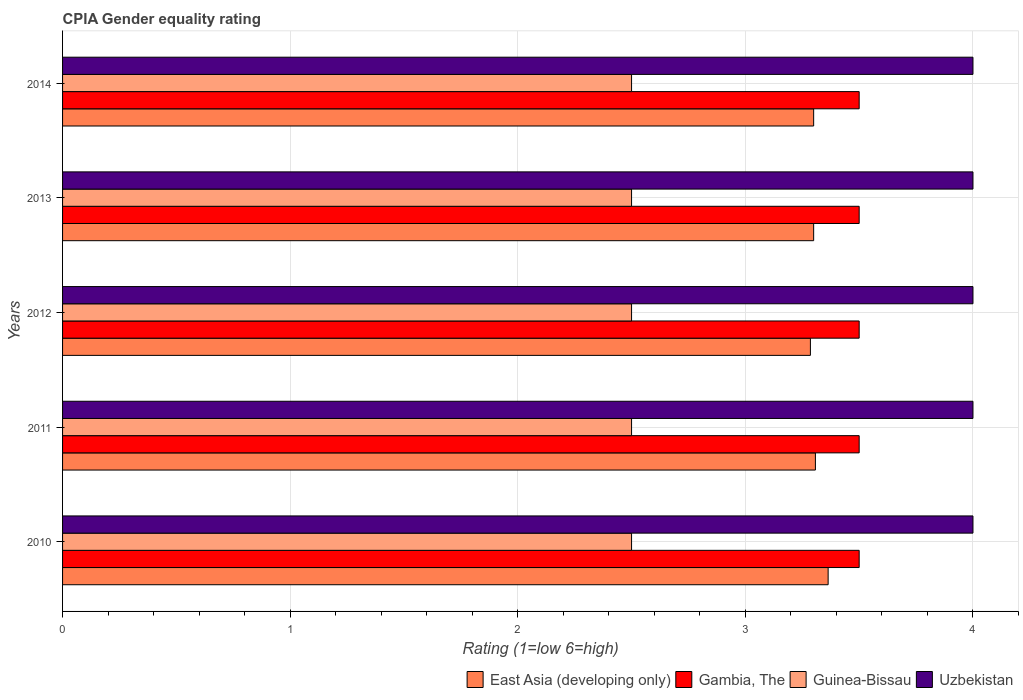How many different coloured bars are there?
Offer a terse response. 4. Are the number of bars on each tick of the Y-axis equal?
Offer a terse response. Yes. How many bars are there on the 4th tick from the bottom?
Give a very brief answer. 4. Across all years, what is the maximum CPIA rating in East Asia (developing only)?
Offer a very short reply. 3.36. In which year was the CPIA rating in Gambia, The maximum?
Make the answer very short. 2010. In which year was the CPIA rating in East Asia (developing only) minimum?
Your answer should be very brief. 2012. In the year 2013, what is the difference between the CPIA rating in East Asia (developing only) and CPIA rating in Guinea-Bissau?
Provide a short and direct response. 0.8. What is the ratio of the CPIA rating in East Asia (developing only) in 2010 to that in 2014?
Keep it short and to the point. 1.02. Is the CPIA rating in East Asia (developing only) in 2013 less than that in 2014?
Your answer should be very brief. No. Is the difference between the CPIA rating in East Asia (developing only) in 2012 and 2014 greater than the difference between the CPIA rating in Guinea-Bissau in 2012 and 2014?
Your response must be concise. No. In how many years, is the CPIA rating in Uzbekistan greater than the average CPIA rating in Uzbekistan taken over all years?
Give a very brief answer. 0. What does the 1st bar from the top in 2010 represents?
Offer a very short reply. Uzbekistan. What does the 3rd bar from the bottom in 2012 represents?
Make the answer very short. Guinea-Bissau. Is it the case that in every year, the sum of the CPIA rating in Gambia, The and CPIA rating in Uzbekistan is greater than the CPIA rating in Guinea-Bissau?
Offer a terse response. Yes. Are all the bars in the graph horizontal?
Your response must be concise. Yes. How many years are there in the graph?
Make the answer very short. 5. Does the graph contain grids?
Offer a terse response. Yes. Where does the legend appear in the graph?
Make the answer very short. Bottom right. What is the title of the graph?
Keep it short and to the point. CPIA Gender equality rating. Does "Belgium" appear as one of the legend labels in the graph?
Your answer should be compact. No. What is the label or title of the X-axis?
Your answer should be compact. Rating (1=low 6=high). What is the Rating (1=low 6=high) in East Asia (developing only) in 2010?
Ensure brevity in your answer.  3.36. What is the Rating (1=low 6=high) of Uzbekistan in 2010?
Offer a terse response. 4. What is the Rating (1=low 6=high) of East Asia (developing only) in 2011?
Keep it short and to the point. 3.31. What is the Rating (1=low 6=high) in Uzbekistan in 2011?
Your answer should be very brief. 4. What is the Rating (1=low 6=high) in East Asia (developing only) in 2012?
Ensure brevity in your answer.  3.29. What is the Rating (1=low 6=high) in Uzbekistan in 2012?
Your response must be concise. 4. What is the Rating (1=low 6=high) of Gambia, The in 2013?
Provide a short and direct response. 3.5. What is the Rating (1=low 6=high) in Uzbekistan in 2014?
Provide a short and direct response. 4. Across all years, what is the maximum Rating (1=low 6=high) of East Asia (developing only)?
Make the answer very short. 3.36. Across all years, what is the maximum Rating (1=low 6=high) of Gambia, The?
Your response must be concise. 3.5. Across all years, what is the minimum Rating (1=low 6=high) of East Asia (developing only)?
Offer a very short reply. 3.29. Across all years, what is the minimum Rating (1=low 6=high) of Gambia, The?
Give a very brief answer. 3.5. Across all years, what is the minimum Rating (1=low 6=high) in Guinea-Bissau?
Offer a very short reply. 2.5. Across all years, what is the minimum Rating (1=low 6=high) in Uzbekistan?
Offer a very short reply. 4. What is the total Rating (1=low 6=high) of East Asia (developing only) in the graph?
Offer a very short reply. 16.56. What is the total Rating (1=low 6=high) in Uzbekistan in the graph?
Keep it short and to the point. 20. What is the difference between the Rating (1=low 6=high) of East Asia (developing only) in 2010 and that in 2011?
Offer a terse response. 0.06. What is the difference between the Rating (1=low 6=high) of East Asia (developing only) in 2010 and that in 2012?
Provide a short and direct response. 0.08. What is the difference between the Rating (1=low 6=high) of Gambia, The in 2010 and that in 2012?
Keep it short and to the point. 0. What is the difference between the Rating (1=low 6=high) in East Asia (developing only) in 2010 and that in 2013?
Your response must be concise. 0.06. What is the difference between the Rating (1=low 6=high) of Guinea-Bissau in 2010 and that in 2013?
Your answer should be compact. 0. What is the difference between the Rating (1=low 6=high) in Uzbekistan in 2010 and that in 2013?
Offer a terse response. 0. What is the difference between the Rating (1=low 6=high) in East Asia (developing only) in 2010 and that in 2014?
Provide a short and direct response. 0.06. What is the difference between the Rating (1=low 6=high) in Guinea-Bissau in 2010 and that in 2014?
Make the answer very short. 0. What is the difference between the Rating (1=low 6=high) of Uzbekistan in 2010 and that in 2014?
Offer a very short reply. 0. What is the difference between the Rating (1=low 6=high) of East Asia (developing only) in 2011 and that in 2012?
Ensure brevity in your answer.  0.02. What is the difference between the Rating (1=low 6=high) of Gambia, The in 2011 and that in 2012?
Offer a terse response. 0. What is the difference between the Rating (1=low 6=high) in Uzbekistan in 2011 and that in 2012?
Ensure brevity in your answer.  0. What is the difference between the Rating (1=low 6=high) of East Asia (developing only) in 2011 and that in 2013?
Your answer should be very brief. 0.01. What is the difference between the Rating (1=low 6=high) in Gambia, The in 2011 and that in 2013?
Keep it short and to the point. 0. What is the difference between the Rating (1=low 6=high) in Uzbekistan in 2011 and that in 2013?
Provide a short and direct response. 0. What is the difference between the Rating (1=low 6=high) of East Asia (developing only) in 2011 and that in 2014?
Provide a short and direct response. 0.01. What is the difference between the Rating (1=low 6=high) of Guinea-Bissau in 2011 and that in 2014?
Offer a very short reply. 0. What is the difference between the Rating (1=low 6=high) in Uzbekistan in 2011 and that in 2014?
Ensure brevity in your answer.  0. What is the difference between the Rating (1=low 6=high) in East Asia (developing only) in 2012 and that in 2013?
Your answer should be compact. -0.01. What is the difference between the Rating (1=low 6=high) of Gambia, The in 2012 and that in 2013?
Your answer should be compact. 0. What is the difference between the Rating (1=low 6=high) of Guinea-Bissau in 2012 and that in 2013?
Offer a very short reply. 0. What is the difference between the Rating (1=low 6=high) in East Asia (developing only) in 2012 and that in 2014?
Ensure brevity in your answer.  -0.01. What is the difference between the Rating (1=low 6=high) of Guinea-Bissau in 2012 and that in 2014?
Provide a short and direct response. 0. What is the difference between the Rating (1=low 6=high) of Uzbekistan in 2013 and that in 2014?
Your response must be concise. 0. What is the difference between the Rating (1=low 6=high) in East Asia (developing only) in 2010 and the Rating (1=low 6=high) in Gambia, The in 2011?
Provide a succinct answer. -0.14. What is the difference between the Rating (1=low 6=high) of East Asia (developing only) in 2010 and the Rating (1=low 6=high) of Guinea-Bissau in 2011?
Make the answer very short. 0.86. What is the difference between the Rating (1=low 6=high) in East Asia (developing only) in 2010 and the Rating (1=low 6=high) in Uzbekistan in 2011?
Ensure brevity in your answer.  -0.64. What is the difference between the Rating (1=low 6=high) of Gambia, The in 2010 and the Rating (1=low 6=high) of Guinea-Bissau in 2011?
Your answer should be very brief. 1. What is the difference between the Rating (1=low 6=high) in Guinea-Bissau in 2010 and the Rating (1=low 6=high) in Uzbekistan in 2011?
Make the answer very short. -1.5. What is the difference between the Rating (1=low 6=high) of East Asia (developing only) in 2010 and the Rating (1=low 6=high) of Gambia, The in 2012?
Offer a terse response. -0.14. What is the difference between the Rating (1=low 6=high) in East Asia (developing only) in 2010 and the Rating (1=low 6=high) in Guinea-Bissau in 2012?
Offer a terse response. 0.86. What is the difference between the Rating (1=low 6=high) of East Asia (developing only) in 2010 and the Rating (1=low 6=high) of Uzbekistan in 2012?
Keep it short and to the point. -0.64. What is the difference between the Rating (1=low 6=high) of Gambia, The in 2010 and the Rating (1=low 6=high) of Guinea-Bissau in 2012?
Ensure brevity in your answer.  1. What is the difference between the Rating (1=low 6=high) of Gambia, The in 2010 and the Rating (1=low 6=high) of Uzbekistan in 2012?
Keep it short and to the point. -0.5. What is the difference between the Rating (1=low 6=high) of Guinea-Bissau in 2010 and the Rating (1=low 6=high) of Uzbekistan in 2012?
Offer a very short reply. -1.5. What is the difference between the Rating (1=low 6=high) in East Asia (developing only) in 2010 and the Rating (1=low 6=high) in Gambia, The in 2013?
Give a very brief answer. -0.14. What is the difference between the Rating (1=low 6=high) of East Asia (developing only) in 2010 and the Rating (1=low 6=high) of Guinea-Bissau in 2013?
Your answer should be very brief. 0.86. What is the difference between the Rating (1=low 6=high) of East Asia (developing only) in 2010 and the Rating (1=low 6=high) of Uzbekistan in 2013?
Provide a short and direct response. -0.64. What is the difference between the Rating (1=low 6=high) in Gambia, The in 2010 and the Rating (1=low 6=high) in Guinea-Bissau in 2013?
Make the answer very short. 1. What is the difference between the Rating (1=low 6=high) of Guinea-Bissau in 2010 and the Rating (1=low 6=high) of Uzbekistan in 2013?
Ensure brevity in your answer.  -1.5. What is the difference between the Rating (1=low 6=high) in East Asia (developing only) in 2010 and the Rating (1=low 6=high) in Gambia, The in 2014?
Your response must be concise. -0.14. What is the difference between the Rating (1=low 6=high) in East Asia (developing only) in 2010 and the Rating (1=low 6=high) in Guinea-Bissau in 2014?
Your answer should be compact. 0.86. What is the difference between the Rating (1=low 6=high) of East Asia (developing only) in 2010 and the Rating (1=low 6=high) of Uzbekistan in 2014?
Provide a short and direct response. -0.64. What is the difference between the Rating (1=low 6=high) of Guinea-Bissau in 2010 and the Rating (1=low 6=high) of Uzbekistan in 2014?
Your answer should be very brief. -1.5. What is the difference between the Rating (1=low 6=high) of East Asia (developing only) in 2011 and the Rating (1=low 6=high) of Gambia, The in 2012?
Provide a short and direct response. -0.19. What is the difference between the Rating (1=low 6=high) of East Asia (developing only) in 2011 and the Rating (1=low 6=high) of Guinea-Bissau in 2012?
Provide a short and direct response. 0.81. What is the difference between the Rating (1=low 6=high) of East Asia (developing only) in 2011 and the Rating (1=low 6=high) of Uzbekistan in 2012?
Offer a terse response. -0.69. What is the difference between the Rating (1=low 6=high) in Gambia, The in 2011 and the Rating (1=low 6=high) in Guinea-Bissau in 2012?
Your response must be concise. 1. What is the difference between the Rating (1=low 6=high) in Gambia, The in 2011 and the Rating (1=low 6=high) in Uzbekistan in 2012?
Offer a terse response. -0.5. What is the difference between the Rating (1=low 6=high) in East Asia (developing only) in 2011 and the Rating (1=low 6=high) in Gambia, The in 2013?
Your response must be concise. -0.19. What is the difference between the Rating (1=low 6=high) in East Asia (developing only) in 2011 and the Rating (1=low 6=high) in Guinea-Bissau in 2013?
Provide a short and direct response. 0.81. What is the difference between the Rating (1=low 6=high) in East Asia (developing only) in 2011 and the Rating (1=low 6=high) in Uzbekistan in 2013?
Keep it short and to the point. -0.69. What is the difference between the Rating (1=low 6=high) in Guinea-Bissau in 2011 and the Rating (1=low 6=high) in Uzbekistan in 2013?
Keep it short and to the point. -1.5. What is the difference between the Rating (1=low 6=high) in East Asia (developing only) in 2011 and the Rating (1=low 6=high) in Gambia, The in 2014?
Give a very brief answer. -0.19. What is the difference between the Rating (1=low 6=high) of East Asia (developing only) in 2011 and the Rating (1=low 6=high) of Guinea-Bissau in 2014?
Offer a terse response. 0.81. What is the difference between the Rating (1=low 6=high) of East Asia (developing only) in 2011 and the Rating (1=low 6=high) of Uzbekistan in 2014?
Your response must be concise. -0.69. What is the difference between the Rating (1=low 6=high) of Guinea-Bissau in 2011 and the Rating (1=low 6=high) of Uzbekistan in 2014?
Your response must be concise. -1.5. What is the difference between the Rating (1=low 6=high) in East Asia (developing only) in 2012 and the Rating (1=low 6=high) in Gambia, The in 2013?
Provide a succinct answer. -0.21. What is the difference between the Rating (1=low 6=high) of East Asia (developing only) in 2012 and the Rating (1=low 6=high) of Guinea-Bissau in 2013?
Offer a very short reply. 0.79. What is the difference between the Rating (1=low 6=high) of East Asia (developing only) in 2012 and the Rating (1=low 6=high) of Uzbekistan in 2013?
Provide a short and direct response. -0.71. What is the difference between the Rating (1=low 6=high) of Gambia, The in 2012 and the Rating (1=low 6=high) of Guinea-Bissau in 2013?
Provide a short and direct response. 1. What is the difference between the Rating (1=low 6=high) in Gambia, The in 2012 and the Rating (1=low 6=high) in Uzbekistan in 2013?
Provide a short and direct response. -0.5. What is the difference between the Rating (1=low 6=high) in East Asia (developing only) in 2012 and the Rating (1=low 6=high) in Gambia, The in 2014?
Your response must be concise. -0.21. What is the difference between the Rating (1=low 6=high) in East Asia (developing only) in 2012 and the Rating (1=low 6=high) in Guinea-Bissau in 2014?
Provide a short and direct response. 0.79. What is the difference between the Rating (1=low 6=high) in East Asia (developing only) in 2012 and the Rating (1=low 6=high) in Uzbekistan in 2014?
Keep it short and to the point. -0.71. What is the average Rating (1=low 6=high) of East Asia (developing only) per year?
Your answer should be very brief. 3.31. What is the average Rating (1=low 6=high) of Gambia, The per year?
Keep it short and to the point. 3.5. What is the average Rating (1=low 6=high) in Guinea-Bissau per year?
Offer a very short reply. 2.5. In the year 2010, what is the difference between the Rating (1=low 6=high) of East Asia (developing only) and Rating (1=low 6=high) of Gambia, The?
Offer a terse response. -0.14. In the year 2010, what is the difference between the Rating (1=low 6=high) of East Asia (developing only) and Rating (1=low 6=high) of Guinea-Bissau?
Your answer should be very brief. 0.86. In the year 2010, what is the difference between the Rating (1=low 6=high) in East Asia (developing only) and Rating (1=low 6=high) in Uzbekistan?
Ensure brevity in your answer.  -0.64. In the year 2010, what is the difference between the Rating (1=low 6=high) of Gambia, The and Rating (1=low 6=high) of Uzbekistan?
Make the answer very short. -0.5. In the year 2010, what is the difference between the Rating (1=low 6=high) of Guinea-Bissau and Rating (1=low 6=high) of Uzbekistan?
Your answer should be very brief. -1.5. In the year 2011, what is the difference between the Rating (1=low 6=high) in East Asia (developing only) and Rating (1=low 6=high) in Gambia, The?
Ensure brevity in your answer.  -0.19. In the year 2011, what is the difference between the Rating (1=low 6=high) of East Asia (developing only) and Rating (1=low 6=high) of Guinea-Bissau?
Offer a terse response. 0.81. In the year 2011, what is the difference between the Rating (1=low 6=high) in East Asia (developing only) and Rating (1=low 6=high) in Uzbekistan?
Provide a succinct answer. -0.69. In the year 2011, what is the difference between the Rating (1=low 6=high) in Gambia, The and Rating (1=low 6=high) in Guinea-Bissau?
Your answer should be compact. 1. In the year 2011, what is the difference between the Rating (1=low 6=high) of Guinea-Bissau and Rating (1=low 6=high) of Uzbekistan?
Make the answer very short. -1.5. In the year 2012, what is the difference between the Rating (1=low 6=high) of East Asia (developing only) and Rating (1=low 6=high) of Gambia, The?
Ensure brevity in your answer.  -0.21. In the year 2012, what is the difference between the Rating (1=low 6=high) of East Asia (developing only) and Rating (1=low 6=high) of Guinea-Bissau?
Your answer should be very brief. 0.79. In the year 2012, what is the difference between the Rating (1=low 6=high) of East Asia (developing only) and Rating (1=low 6=high) of Uzbekistan?
Give a very brief answer. -0.71. In the year 2012, what is the difference between the Rating (1=low 6=high) in Gambia, The and Rating (1=low 6=high) in Uzbekistan?
Offer a terse response. -0.5. In the year 2013, what is the difference between the Rating (1=low 6=high) of East Asia (developing only) and Rating (1=low 6=high) of Uzbekistan?
Give a very brief answer. -0.7. In the year 2013, what is the difference between the Rating (1=low 6=high) of Gambia, The and Rating (1=low 6=high) of Uzbekistan?
Offer a very short reply. -0.5. In the year 2013, what is the difference between the Rating (1=low 6=high) in Guinea-Bissau and Rating (1=low 6=high) in Uzbekistan?
Provide a succinct answer. -1.5. In the year 2014, what is the difference between the Rating (1=low 6=high) of East Asia (developing only) and Rating (1=low 6=high) of Gambia, The?
Make the answer very short. -0.2. What is the ratio of the Rating (1=low 6=high) of East Asia (developing only) in 2010 to that in 2011?
Give a very brief answer. 1.02. What is the ratio of the Rating (1=low 6=high) in Gambia, The in 2010 to that in 2011?
Provide a short and direct response. 1. What is the ratio of the Rating (1=low 6=high) in East Asia (developing only) in 2010 to that in 2012?
Your answer should be compact. 1.02. What is the ratio of the Rating (1=low 6=high) of Gambia, The in 2010 to that in 2012?
Your answer should be very brief. 1. What is the ratio of the Rating (1=low 6=high) of Guinea-Bissau in 2010 to that in 2012?
Your response must be concise. 1. What is the ratio of the Rating (1=low 6=high) of East Asia (developing only) in 2010 to that in 2013?
Offer a terse response. 1.02. What is the ratio of the Rating (1=low 6=high) of Gambia, The in 2010 to that in 2013?
Your answer should be compact. 1. What is the ratio of the Rating (1=low 6=high) in Guinea-Bissau in 2010 to that in 2013?
Your response must be concise. 1. What is the ratio of the Rating (1=low 6=high) in East Asia (developing only) in 2010 to that in 2014?
Make the answer very short. 1.02. What is the ratio of the Rating (1=low 6=high) in Gambia, The in 2010 to that in 2014?
Provide a succinct answer. 1. What is the ratio of the Rating (1=low 6=high) of Guinea-Bissau in 2010 to that in 2014?
Offer a terse response. 1. What is the ratio of the Rating (1=low 6=high) of East Asia (developing only) in 2011 to that in 2012?
Your answer should be very brief. 1.01. What is the ratio of the Rating (1=low 6=high) in Guinea-Bissau in 2011 to that in 2012?
Provide a short and direct response. 1. What is the ratio of the Rating (1=low 6=high) of East Asia (developing only) in 2011 to that in 2013?
Offer a very short reply. 1. What is the ratio of the Rating (1=low 6=high) of Gambia, The in 2011 to that in 2013?
Keep it short and to the point. 1. What is the ratio of the Rating (1=low 6=high) of Uzbekistan in 2011 to that in 2013?
Make the answer very short. 1. What is the ratio of the Rating (1=low 6=high) in Guinea-Bissau in 2011 to that in 2014?
Provide a short and direct response. 1. What is the ratio of the Rating (1=low 6=high) in East Asia (developing only) in 2012 to that in 2013?
Provide a short and direct response. 1. What is the ratio of the Rating (1=low 6=high) of Guinea-Bissau in 2012 to that in 2013?
Your response must be concise. 1. What is the ratio of the Rating (1=low 6=high) in Uzbekistan in 2012 to that in 2013?
Make the answer very short. 1. What is the ratio of the Rating (1=low 6=high) of East Asia (developing only) in 2012 to that in 2014?
Ensure brevity in your answer.  1. What is the ratio of the Rating (1=low 6=high) of Uzbekistan in 2012 to that in 2014?
Your answer should be very brief. 1. What is the ratio of the Rating (1=low 6=high) in Uzbekistan in 2013 to that in 2014?
Make the answer very short. 1. What is the difference between the highest and the second highest Rating (1=low 6=high) of East Asia (developing only)?
Provide a short and direct response. 0.06. What is the difference between the highest and the second highest Rating (1=low 6=high) of Guinea-Bissau?
Make the answer very short. 0. What is the difference between the highest and the second highest Rating (1=low 6=high) in Uzbekistan?
Your response must be concise. 0. What is the difference between the highest and the lowest Rating (1=low 6=high) of East Asia (developing only)?
Offer a very short reply. 0.08. What is the difference between the highest and the lowest Rating (1=low 6=high) of Gambia, The?
Offer a terse response. 0. What is the difference between the highest and the lowest Rating (1=low 6=high) in Guinea-Bissau?
Offer a very short reply. 0. What is the difference between the highest and the lowest Rating (1=low 6=high) in Uzbekistan?
Provide a succinct answer. 0. 